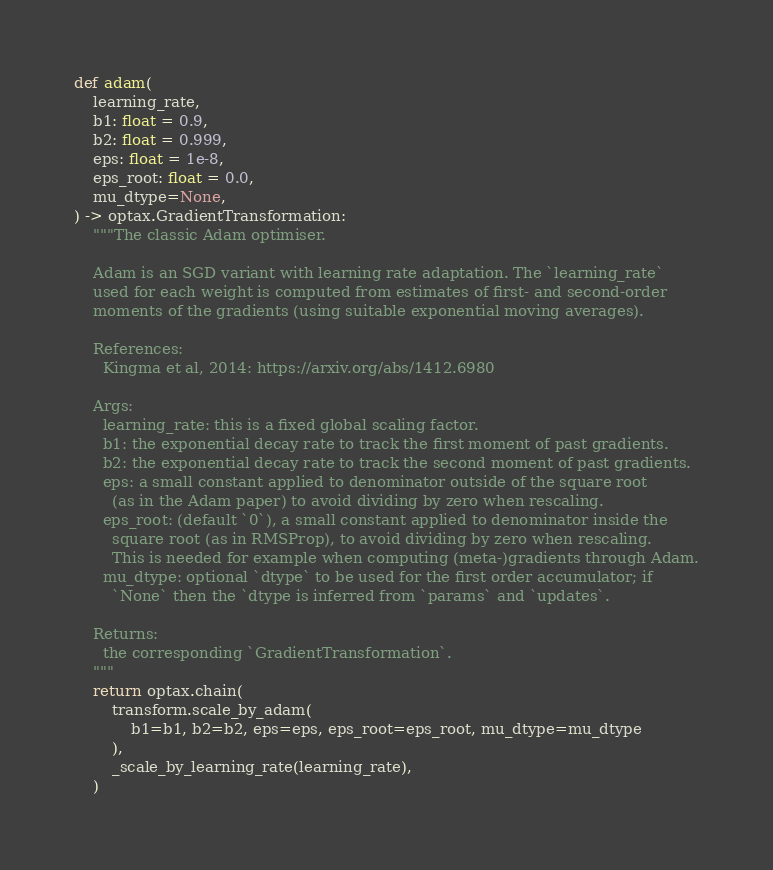Convert code to text. <code><loc_0><loc_0><loc_500><loc_500><_Python_>

def adam(
    learning_rate,
    b1: float = 0.9,
    b2: float = 0.999,
    eps: float = 1e-8,
    eps_root: float = 0.0,
    mu_dtype=None,
) -> optax.GradientTransformation:
    """The classic Adam optimiser.

    Adam is an SGD variant with learning rate adaptation. The `learning_rate`
    used for each weight is computed from estimates of first- and second-order
    moments of the gradients (using suitable exponential moving averages).

    References:
      Kingma et al, 2014: https://arxiv.org/abs/1412.6980

    Args:
      learning_rate: this is a fixed global scaling factor.
      b1: the exponential decay rate to track the first moment of past gradients.
      b2: the exponential decay rate to track the second moment of past gradients.
      eps: a small constant applied to denominator outside of the square root
        (as in the Adam paper) to avoid dividing by zero when rescaling.
      eps_root: (default `0`), a small constant applied to denominator inside the
        square root (as in RMSProp), to avoid dividing by zero when rescaling.
        This is needed for example when computing (meta-)gradients through Adam.
      mu_dtype: optional `dtype` to be used for the first order accumulator; if
        `None` then the `dtype is inferred from `params` and `updates`.

    Returns:
      the corresponding `GradientTransformation`.
    """
    return optax.chain(
        transform.scale_by_adam(
            b1=b1, b2=b2, eps=eps, eps_root=eps_root, mu_dtype=mu_dtype
        ),
        _scale_by_learning_rate(learning_rate),
    )
</code> 